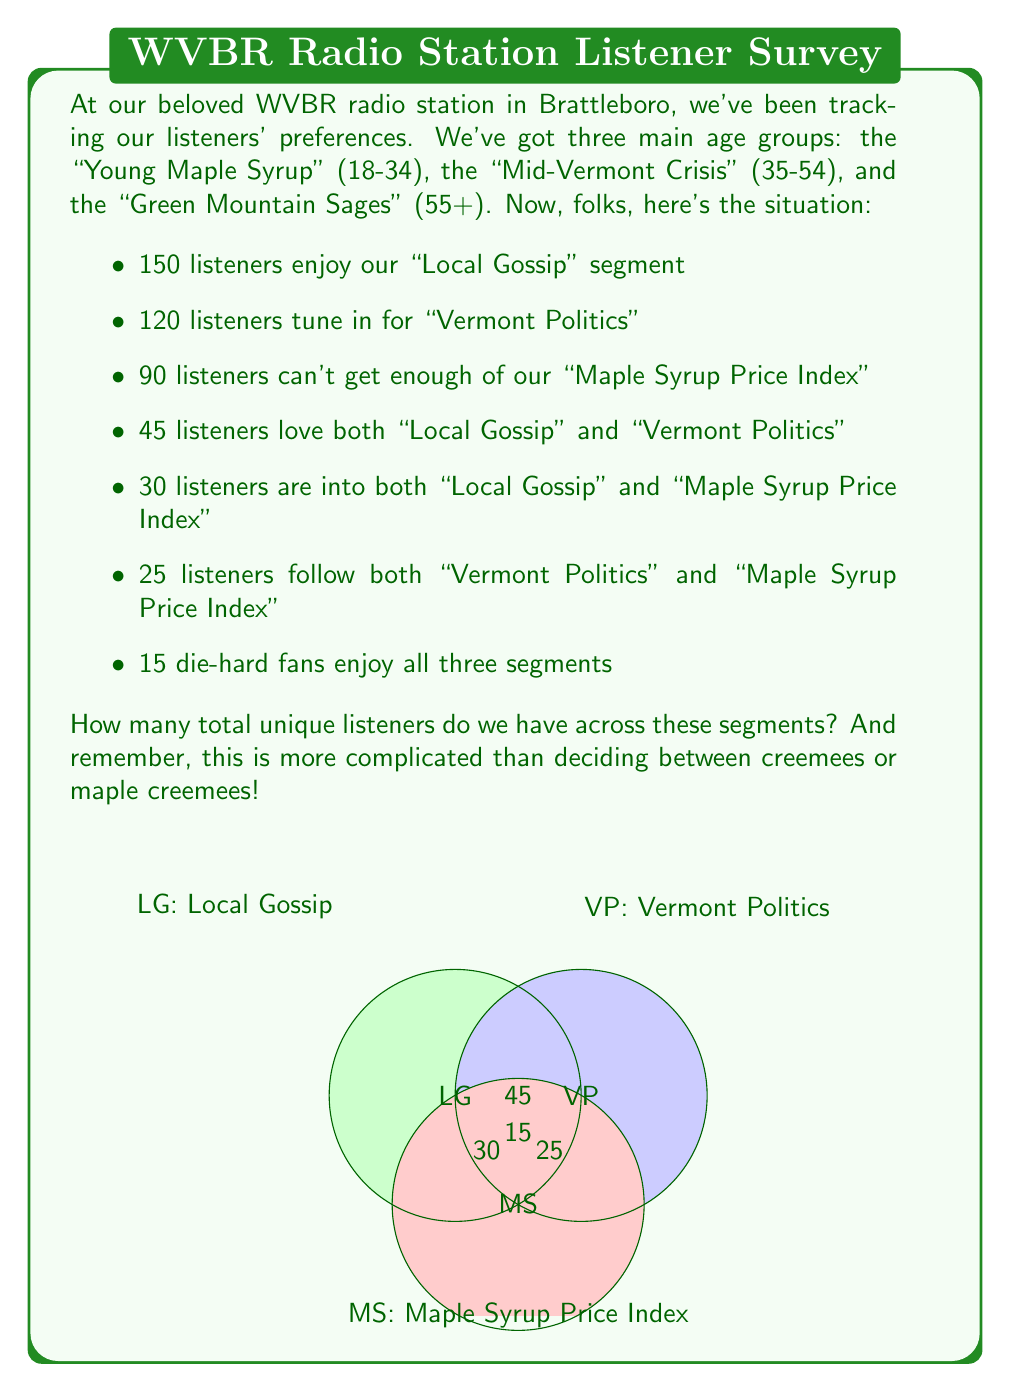Provide a solution to this math problem. Alright, let's break this down step-by-step, just like we'd dissect a town hall meeting:

1) First, we'll use the inclusion-exclusion principle. The formula for three sets A, B, and C is:

   $$|A \cup B \cup C| = |A| + |B| + |C| - |A \cap B| - |A \cap C| - |B \cap C| + |A \cap B \cap C|$$

2) Let's assign our sets:
   A: Local Gossip (LG)
   B: Vermont Politics (VP)
   C: Maple Syrup Price Index (MS)

3) We know:
   $|A| = 150$, $|B| = 120$, $|C| = 90$
   $|A \cap B| = 45$, $|A \cap C| = 30$, $|B \cap C| = 25$
   $|A \cap B \cap C| = 15$

4) Now, let's plug these values into our formula:

   $$|A \cup B \cup C| = 150 + 120 + 90 - 45 - 30 - 25 + 15$$

5) Let's calculate:
   $$|A \cup B \cup C| = 360 - 100 + 15 = 275$$

So, just like how we all come together for the Strolling of the Heifers parade, we've united our listener numbers!
Answer: 275 unique listeners 